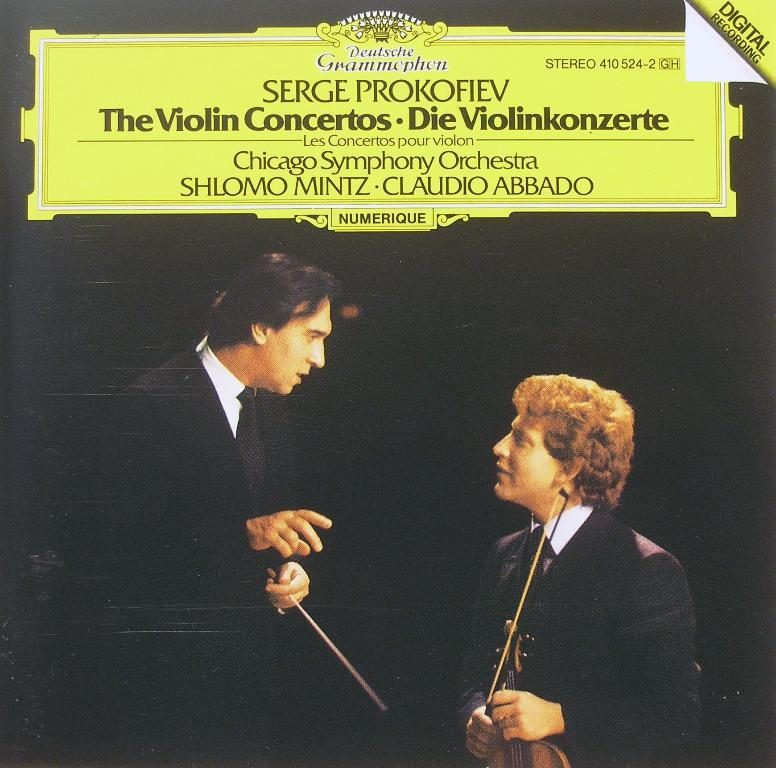What can be seen in the image besides the two men? There is a poster in the image. What are the two men doing in the image? One of the men is holding a violin. What is written or displayed at the top of the image? There is some text at the top of the image. Can you see a cub biting the foot of one of the men in the image? No, there is no cub or any indication of a foot being bitten in the image. 